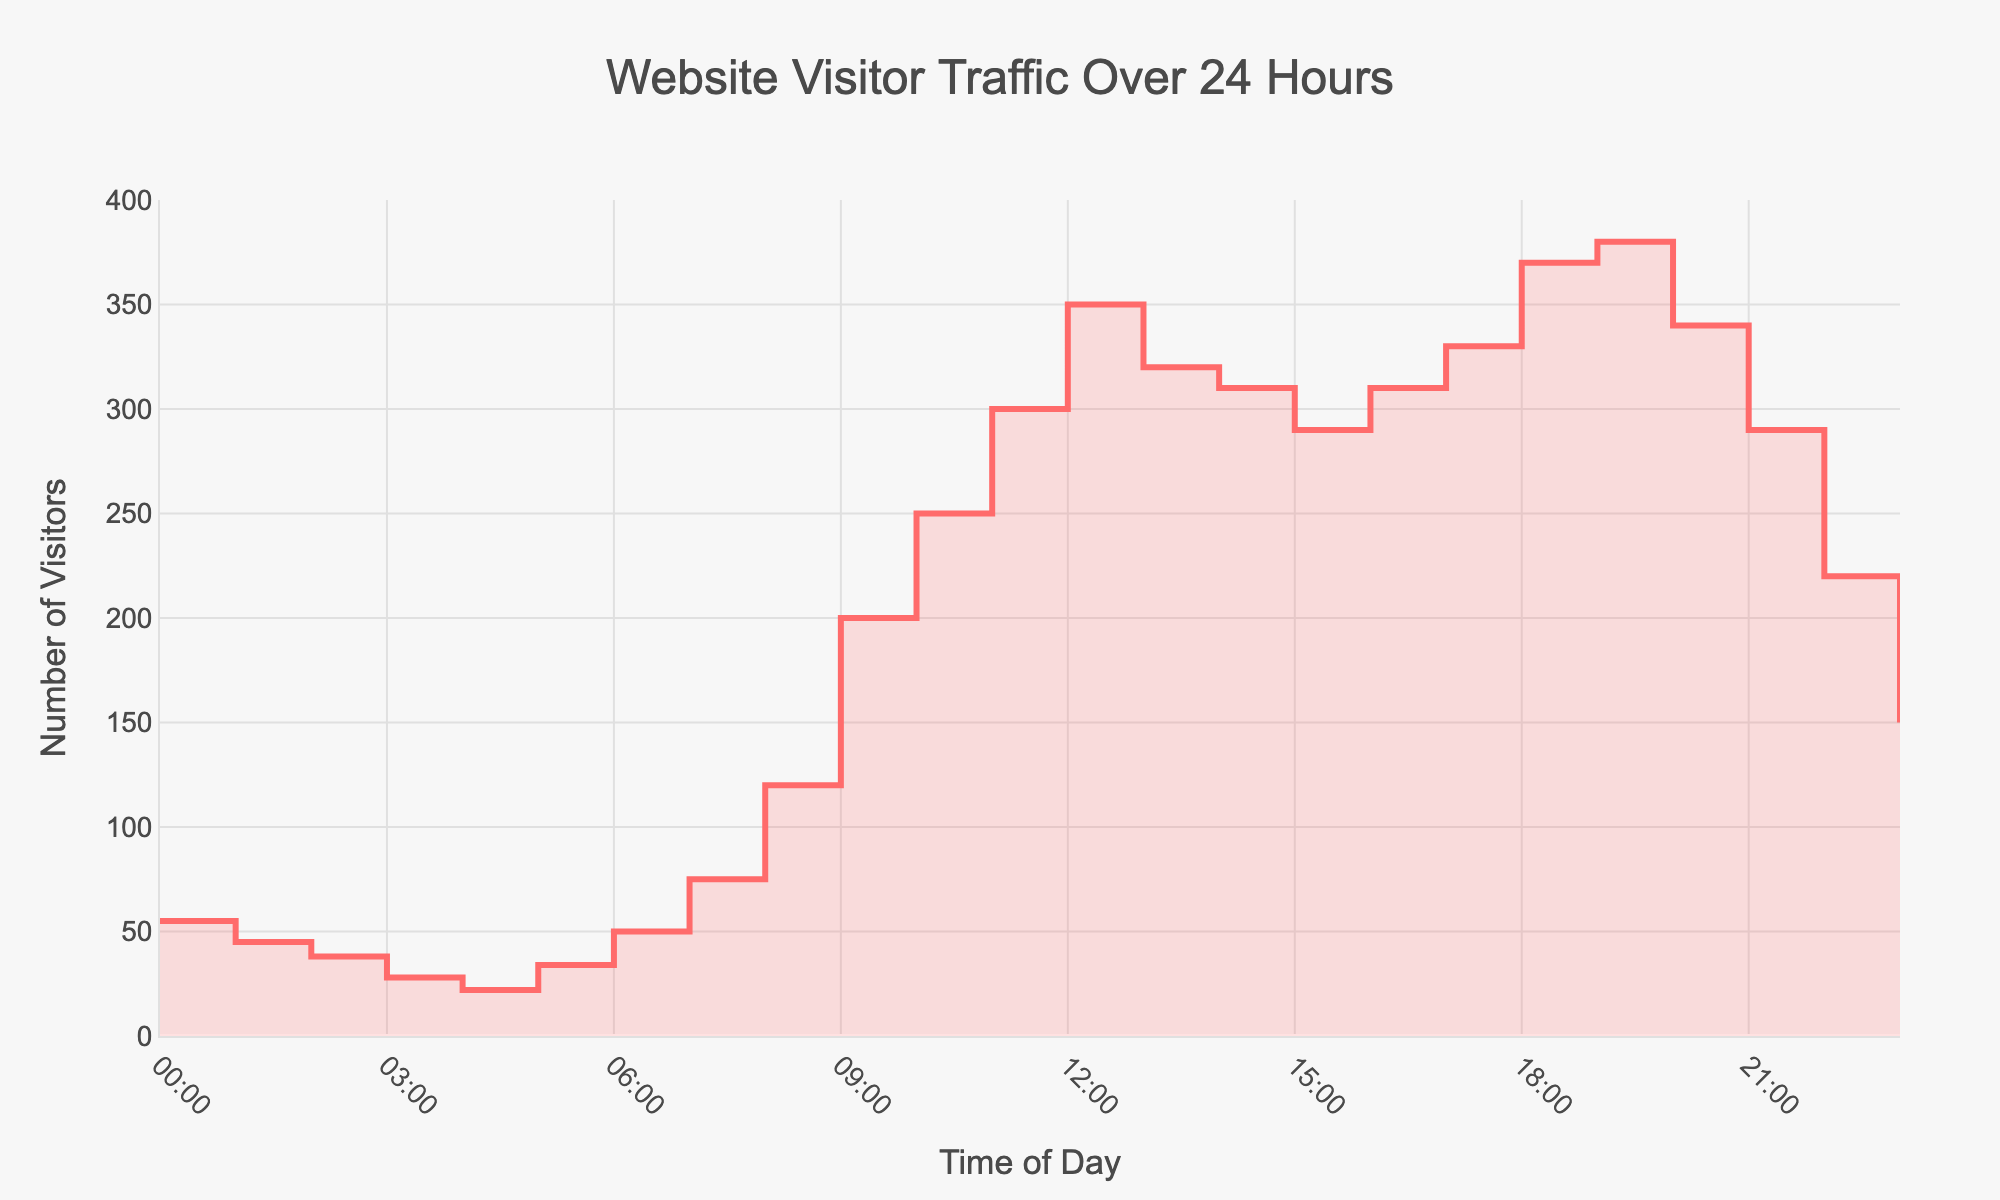What trend does the visitor traffic follow during the early morning hours? From 00:00 to 05:00, visitor traffic generally decreases, starting from 55 visitors at 00:00 to 22 visitors at 04:00, with a slight increase to 34 visitors at 05:00.
Answer: Decreases, then slight increase At what time is the peak website visitor traffic observed? The peak website visitor traffic is observed at the point with the highest number of visitors. This occurs at 12:00, where the number of visitors is 350.
Answer: 12:00 What is the visitor count at 17:00? The visitor count at 17:00 is displayed directly on the stair plot for that hour. It is 330 visitors.
Answer: 330 How many times does the visitor count exceed 300? Count the number of data points where the visitor count is greater than 300. These times are 11:00, 12:00, 13:00, 16:00, 17:00, 18:00, and 19:00. So, the count is 7.
Answer: 7 times What is the average visitor count during the evening hours (18:00 to 23:00)? Add the visitor counts for the hours 18:00, 19:00, 20:00, 21:00, 22:00, and 23:00, then divide by the number of hours (6). (370 + 380 + 340 + 290 + 220 + 150) / 6 = 1750 / 6 = 291.67.
Answer: 291.67 During which hour is there a noticeable dip in visitor traffic in the evening? Identify the hour in the evening where there is a significant drop in traffic relative to the previous hour. The visitor count drops from 380 at 19:00 to 340 at 20:00.
Answer: 20:00 What proportion of the total visitor count occurs before noon (00:00 to 11:00)? First, add the visitor counts from 00:00 to 11:00. Then find the proportion this sum represents from the total visitor count of the entire day. Total before noon = 55 + 45 + 38 + 28 + 22 + 34 + 50 + 75 + 120 + 200 + 250 + 300 = 1217. Sum the total for the day. Total visitors for the entire day = 5555. Proportion is 1217 / 5555 ≈ 0.219.
Answer: 21.9% By how much does the visitor count increase from 08:00 to 09:00? Subtract the visitor count at 08:00 from the count at 09:00. Visitor count at 09:00 = 200, and at 08:00 = 120. So, the increase is 200 - 120 = 80.
Answer: 80 Which hour of the day has the lowest visitor count, and what is it? Identify the hour with the lowest visitor count from the given data. The lowest visitor count is 22 at 04:00.
Answer: 04:00, 22 What is the total visitor count from 12:00 to 18:00? Sum the visitor counts from 12:00 to 18:00. 350 (12:00) + 320 (13:00) + 310 (14:00) + 290 (15:00) + 310 (16:00) + 330 (17:00) + 370 (18:00) = 2280.
Answer: 2280 